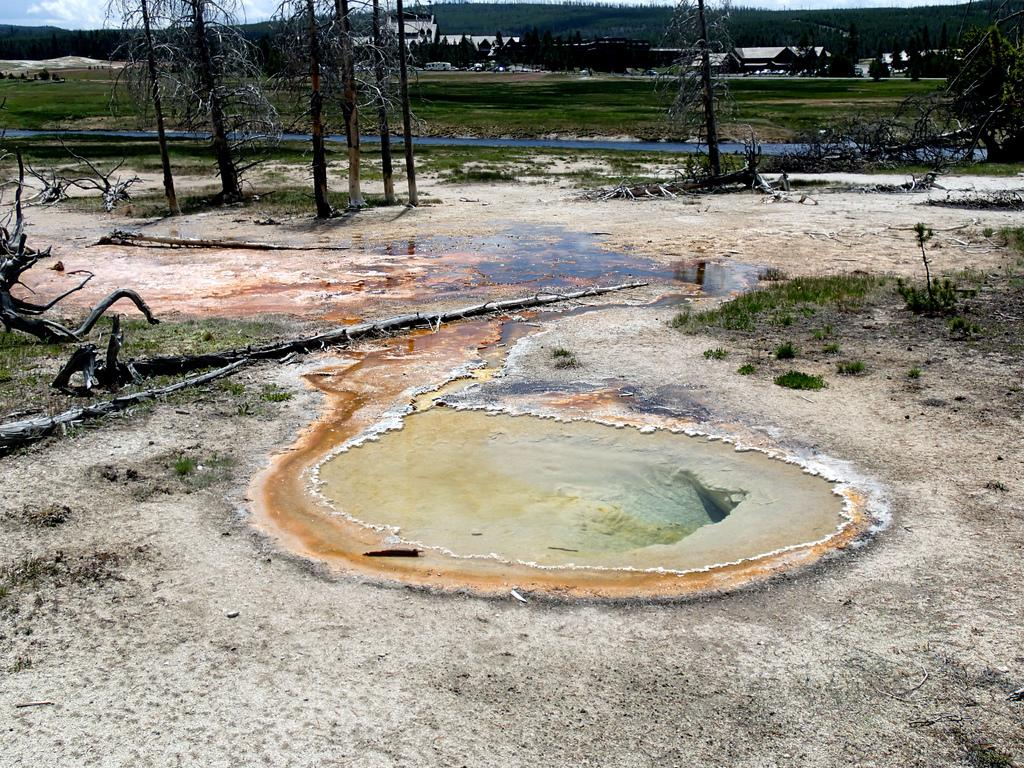What type of body of water is present in the image? There is a pond in the image. What type of vegetation can be seen in the image? There are trees and grass in the image. What type of structures are visible in the image? There are buildings in the image. What type of geographical feature can be seen in the image? There are hills in the image. What part of the natural environment is visible in the image? The sky is visible in the image, and there are clouds in the sky. How many babies are pushing the animal in the image? There are no babies or animals present in the image. What type of animal can be seen interacting with the pond in the image? There is no animal present in the image; only the pond, trees, grass, buildings, hills, sky, and clouds are visible. 